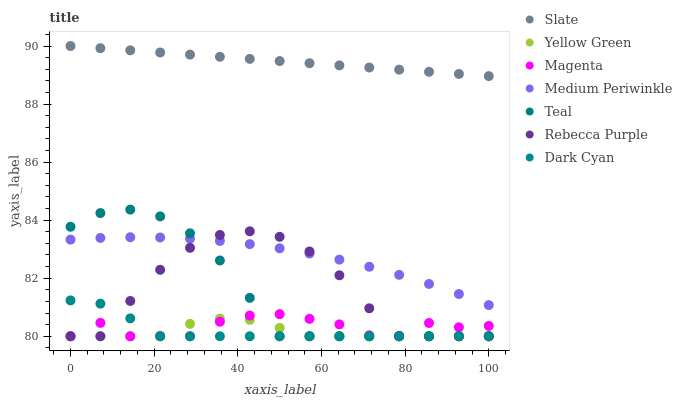Does Yellow Green have the minimum area under the curve?
Answer yes or no. Yes. Does Slate have the maximum area under the curve?
Answer yes or no. Yes. Does Medium Periwinkle have the minimum area under the curve?
Answer yes or no. No. Does Medium Periwinkle have the maximum area under the curve?
Answer yes or no. No. Is Slate the smoothest?
Answer yes or no. Yes. Is Rebecca Purple the roughest?
Answer yes or no. Yes. Is Medium Periwinkle the smoothest?
Answer yes or no. No. Is Medium Periwinkle the roughest?
Answer yes or no. No. Does Yellow Green have the lowest value?
Answer yes or no. Yes. Does Medium Periwinkle have the lowest value?
Answer yes or no. No. Does Slate have the highest value?
Answer yes or no. Yes. Does Medium Periwinkle have the highest value?
Answer yes or no. No. Is Yellow Green less than Medium Periwinkle?
Answer yes or no. Yes. Is Slate greater than Teal?
Answer yes or no. Yes. Does Rebecca Purple intersect Medium Periwinkle?
Answer yes or no. Yes. Is Rebecca Purple less than Medium Periwinkle?
Answer yes or no. No. Is Rebecca Purple greater than Medium Periwinkle?
Answer yes or no. No. Does Yellow Green intersect Medium Periwinkle?
Answer yes or no. No. 